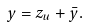<formula> <loc_0><loc_0><loc_500><loc_500>y = z _ { u } + \bar { y } .</formula> 